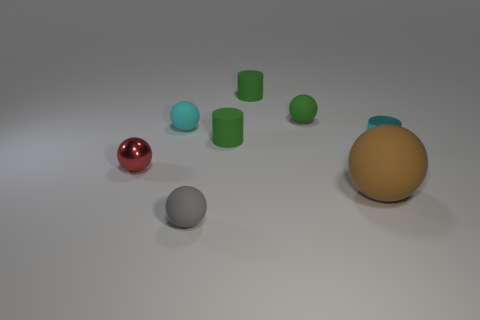How many objects are either small cyan rubber objects or tiny matte balls that are behind the gray rubber thing? Taking a closer look at the image behind the gray rubber object, there appears to be one tiny matte ball and one small cyan rubber object, making a total of two objects that fit the description. 